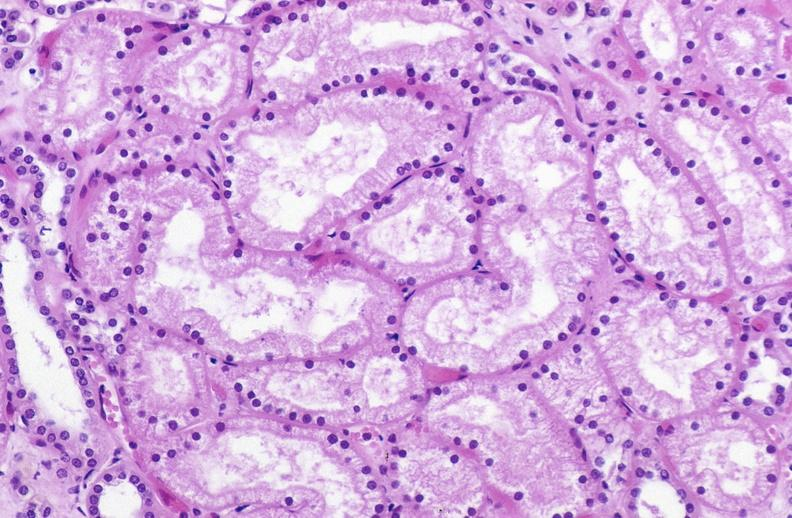what is present?
Answer the question using a single word or phrase. Urinary 